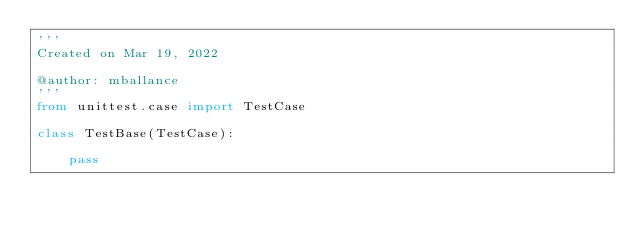Convert code to text. <code><loc_0><loc_0><loc_500><loc_500><_Python_>'''
Created on Mar 19, 2022

@author: mballance
'''
from unittest.case import TestCase

class TestBase(TestCase):
    
    pass</code> 